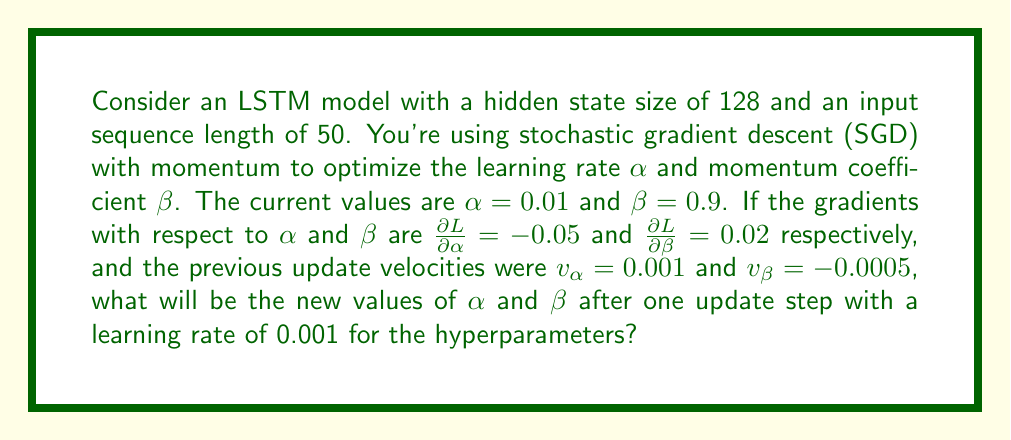Show me your answer to this math problem. Let's approach this step-by-step:

1) In SGD with momentum, we update the parameters using two equations:
   
   $$v_t = \beta v_{t-1} + (1-\beta)\nabla_\theta L(\theta)$$
   $$\theta_t = \theta_{t-1} - \alpha v_t$$

   Where $v_t$ is the velocity, $\beta$ is the momentum coefficient, and $\alpha$ is the learning rate.

2) For the learning rate $\alpha$:
   - Current $\alpha = 0.01$
   - $\frac{\partial L}{\partial \alpha} = -0.05$
   - Previous $v_\alpha = 0.001$
   - Hyperparameter learning rate = 0.001

   First, update the velocity:
   $$v_\alpha = 0.9 \cdot 0.001 + (1-0.9) \cdot (-0.05) = 0.0009 - 0.005 = -0.0041$$

   Then, update $\alpha$:
   $$\alpha_{new} = 0.01 - 0.001 \cdot (-0.0041) = 0.01 + 0.0000041 = 0.0100041$$

3) For the momentum coefficient $\beta$:
   - Current $\beta = 0.9$
   - $\frac{\partial L}{\partial \beta} = 0.02$
   - Previous $v_\beta = -0.0005$
   - Hyperparameter learning rate = 0.001

   First, update the velocity:
   $$v_\beta = 0.9 \cdot (-0.0005) + (1-0.9) \cdot 0.02 = -0.00045 + 0.002 = 0.00155$$

   Then, update $\beta$:
   $$\beta_{new} = 0.9 - 0.001 \cdot 0.00155 = 0.9 - 0.00000155 = 0.89999845$$
Answer: $\alpha_{new} = 0.0100041$, $\beta_{new} = 0.89999845$ 